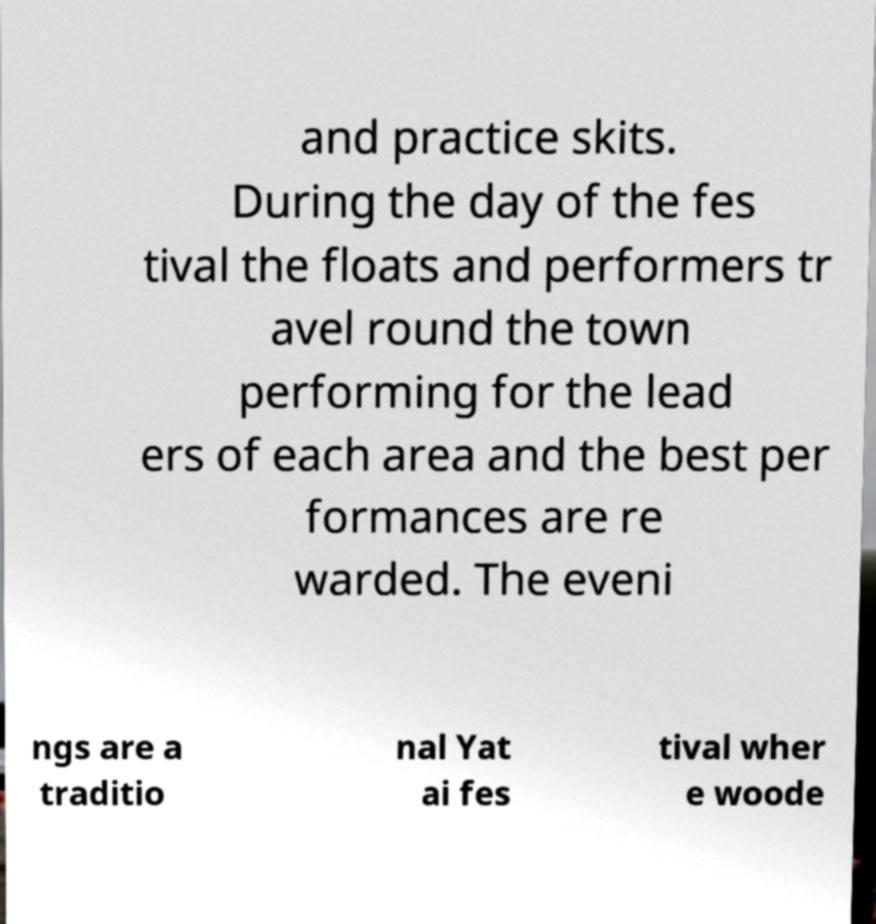Please identify and transcribe the text found in this image. and practice skits. During the day of the fes tival the floats and performers tr avel round the town performing for the lead ers of each area and the best per formances are re warded. The eveni ngs are a traditio nal Yat ai fes tival wher e woode 